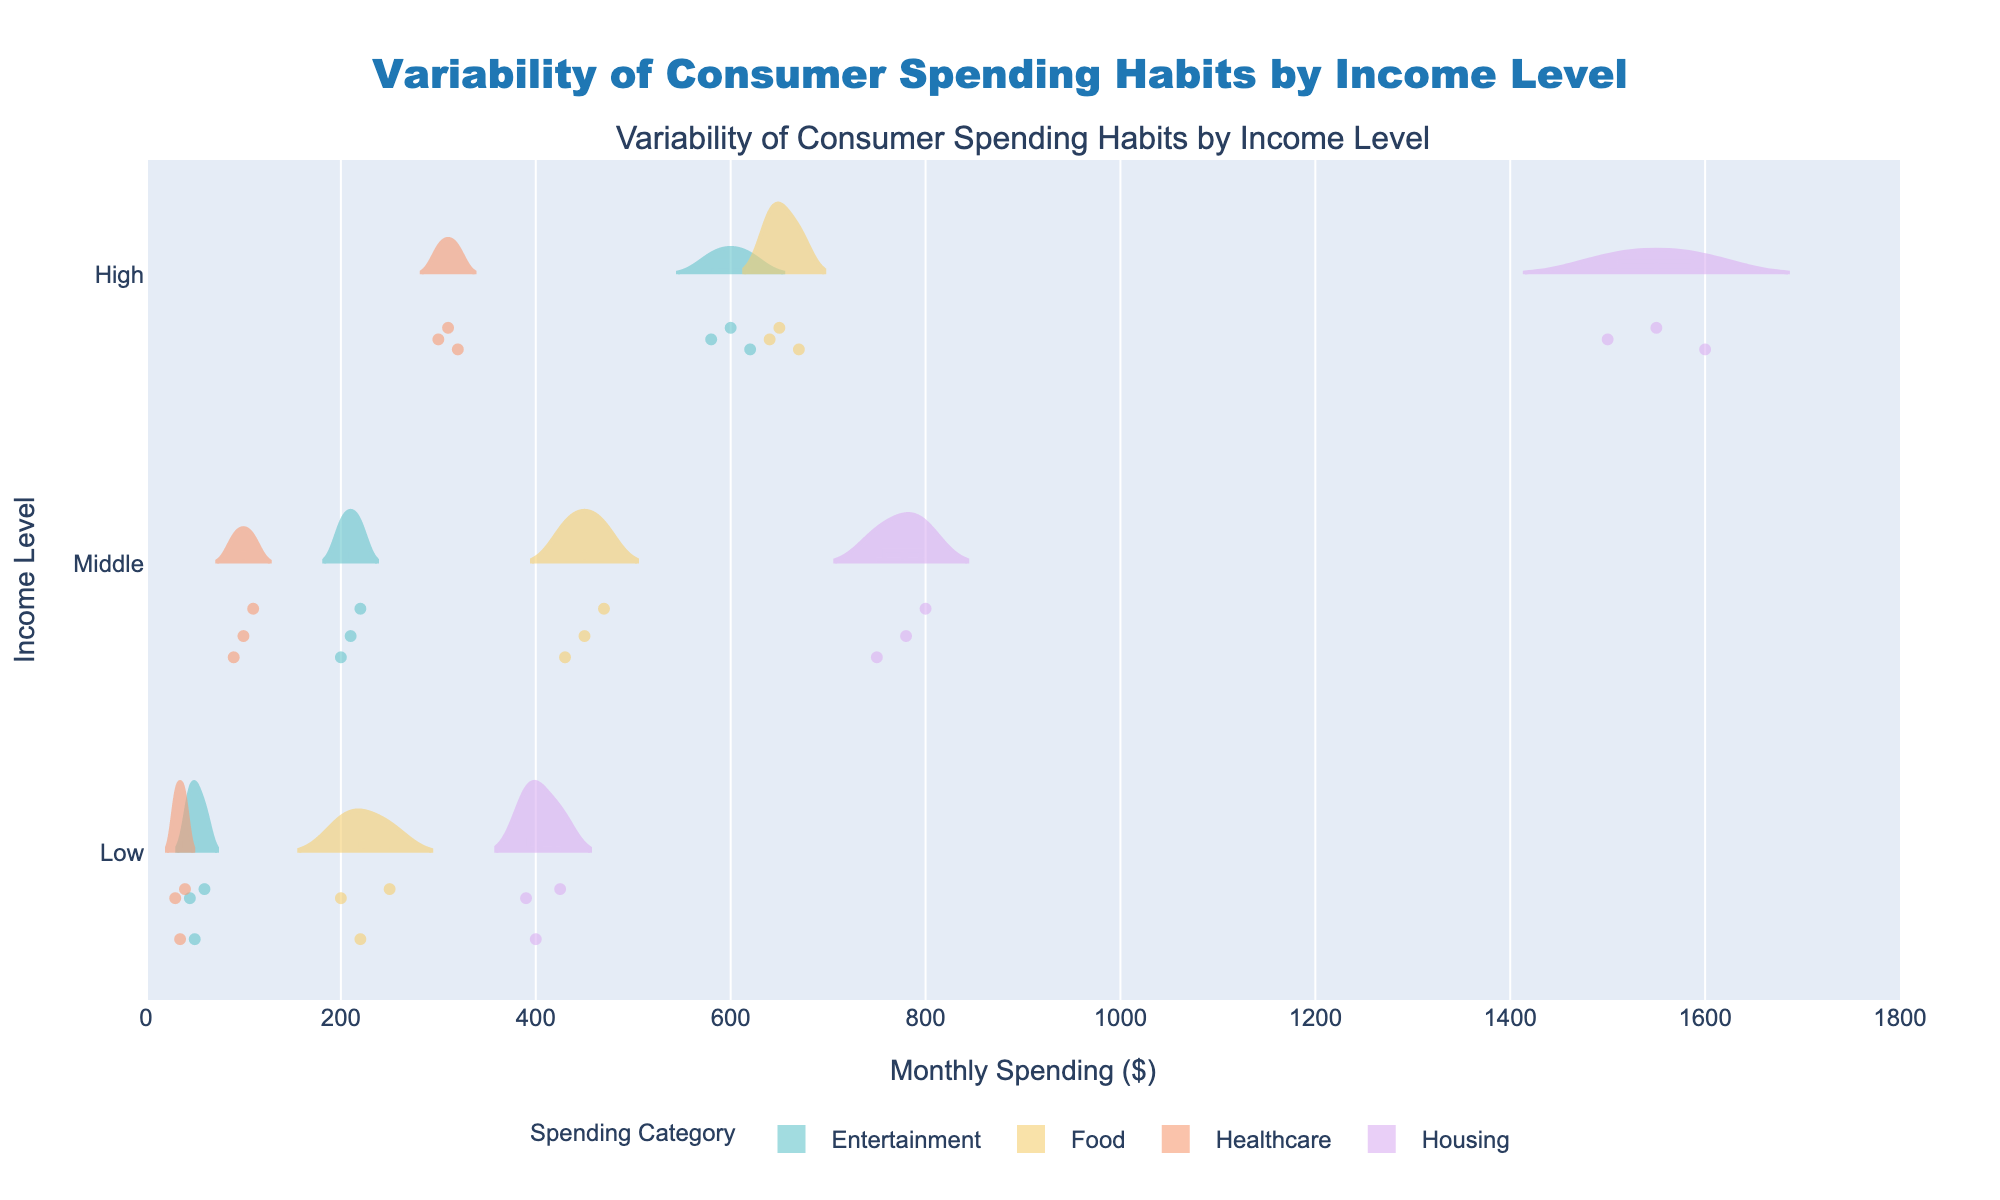What is the title of the plot? The title of the plot is displayed prominently at the top. It states, "Variability of Consumer Spending Habits by Income Level".
Answer: Variability of Consumer Spending Habits by Income Level Which spending category has the highest median monthly spending for the High-income level? By examining the violins for the High-income level, we notice that Housing is the category that has the highest median with values around 1550.
Answer: Housing How do the monthly spending distributions on Food compare between Low and High income levels? Observing the violins for the Food category: Low-income level has more compact distribution with values around 200-250, while High-income level has more spread distribution around 640-670. The High-income level has higher spending than Low-income on Food.
Answer: High-income level spends more on Food than Low-income level Which spending category shows the least variation in monthly spending for the Middle-income level? By examining the width and compactness of the violins for Middle-income level, Healthcare has the least variation, as the values are closely packed between 90 and 110.
Answer: Healthcare Between which income levels does Entertainment spending show the largest difference? Looking at the violins for Entertainment, the High-income level has values around 580-620, whereas the Low-income level has values around 45-60. The difference between these two levels is the largest.
Answer: Between High and Low What are the maximum and minimum monthly spending values for Healthcare in the Low-income level? Checking the distribution for Healthcare at the Low-income level, the maximum and minimum values are approximately 40 and 30, respectively.
Answer: Maximum: 40, Minimum: 30 On average, which income level spends more on Housing? By looking at the mean lines inside the violins for Housing, High-income level spends more as its mean is around 1550 compared to Middle-income (around 775) and Low-income (around 405).
Answer: High-income level What is the total range of monthly spending observed for Housing at the High-income level? The range is determined by subtracting the lowest value in the violin's range from the highest value. For High-income level in Housing, it ranges approximately from 1500 to 1600. So, 1600 - 1500 = 100.
Answer: 100 Which spending category shows overlapping spending patterns between Middle and High income levels? The violins for Entertainment show significant overlap in their spending distributions between Middle and High-income levels, with values around 200-220 for Middle and 580-620 for High partially overlapping.
Answer: Entertainment 